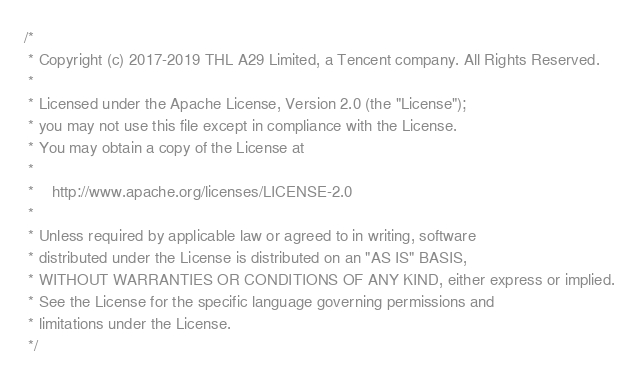Convert code to text. <code><loc_0><loc_0><loc_500><loc_500><_C++_>/*
 * Copyright (c) 2017-2019 THL A29 Limited, a Tencent company. All Rights Reserved.
 *
 * Licensed under the Apache License, Version 2.0 (the "License");
 * you may not use this file except in compliance with the License.
 * You may obtain a copy of the License at
 *
 *    http://www.apache.org/licenses/LICENSE-2.0
 *
 * Unless required by applicable law or agreed to in writing, software
 * distributed under the License is distributed on an "AS IS" BASIS,
 * WITHOUT WARRANTIES OR CONDITIONS OF ANY KIND, either express or implied.
 * See the License for the specific language governing permissions and
 * limitations under the License.
 */
</code> 